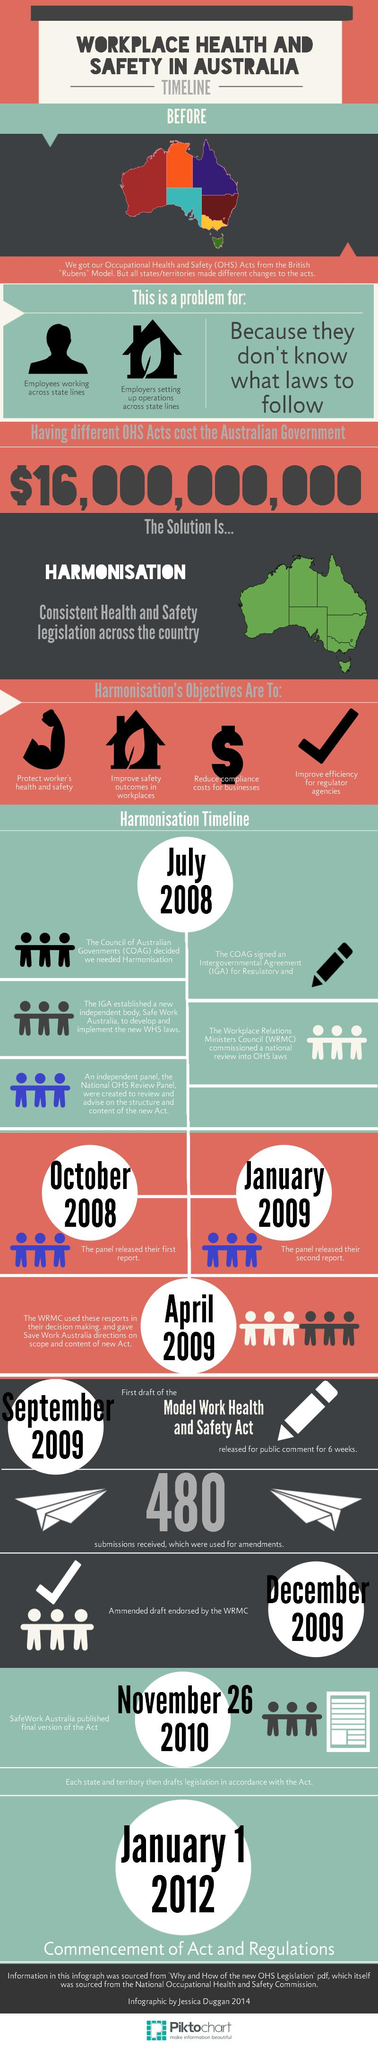Mention a couple of crucial points in this snapshot. There are four objectives for harmonization. The use of the tick sign in the harmonization objective indicates a focus on improving efficiency for regulator agencies through the harmonization of standards and practices. The first report of the panel was released in October 2008. The commencement of the Acts and regulations took place three years after the second report by the panel. The purpose of harmonization is to lessen the expenses incurred by businesses in complying with various regulations. 